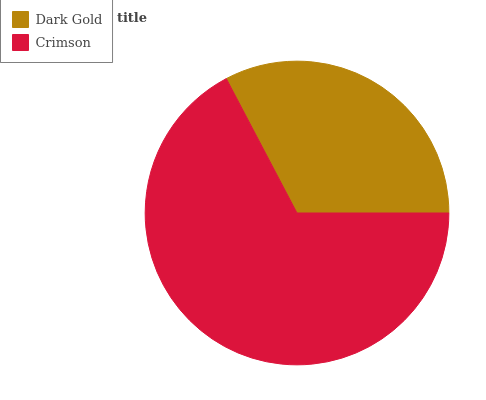Is Dark Gold the minimum?
Answer yes or no. Yes. Is Crimson the maximum?
Answer yes or no. Yes. Is Crimson the minimum?
Answer yes or no. No. Is Crimson greater than Dark Gold?
Answer yes or no. Yes. Is Dark Gold less than Crimson?
Answer yes or no. Yes. Is Dark Gold greater than Crimson?
Answer yes or no. No. Is Crimson less than Dark Gold?
Answer yes or no. No. Is Crimson the high median?
Answer yes or no. Yes. Is Dark Gold the low median?
Answer yes or no. Yes. Is Dark Gold the high median?
Answer yes or no. No. Is Crimson the low median?
Answer yes or no. No. 